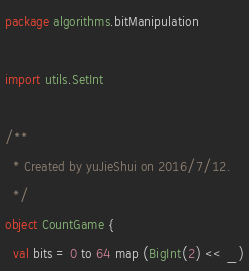Convert code to text. <code><loc_0><loc_0><loc_500><loc_500><_Scala_>package algorithms.bitManipulation

import utils.SetInt

/**
  * Created by yuJieShui on 2016/7/12.
  */
object CountGame {
  val bits = 0 to 64 map (BigInt(2) << _)
</code> 